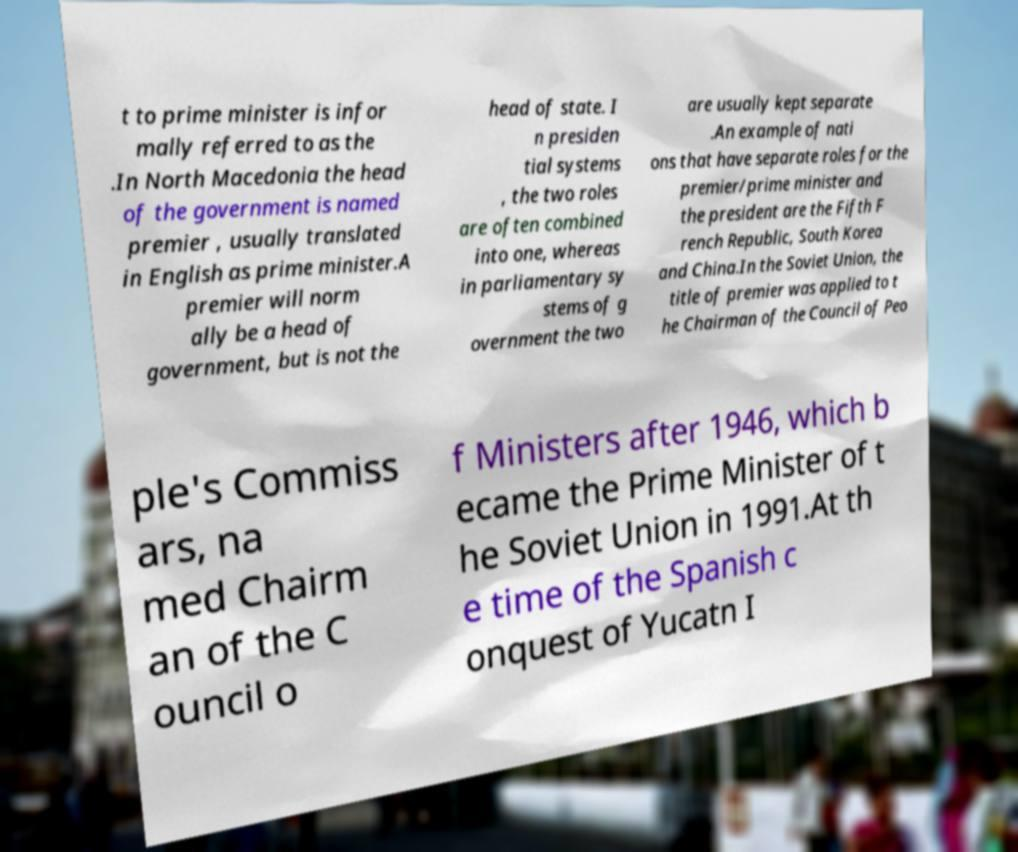Could you extract and type out the text from this image? t to prime minister is infor mally referred to as the .In North Macedonia the head of the government is named premier , usually translated in English as prime minister.A premier will norm ally be a head of government, but is not the head of state. I n presiden tial systems , the two roles are often combined into one, whereas in parliamentary sy stems of g overnment the two are usually kept separate .An example of nati ons that have separate roles for the premier/prime minister and the president are the Fifth F rench Republic, South Korea and China.In the Soviet Union, the title of premier was applied to t he Chairman of the Council of Peo ple's Commiss ars, na med Chairm an of the C ouncil o f Ministers after 1946, which b ecame the Prime Minister of t he Soviet Union in 1991.At th e time of the Spanish c onquest of Yucatn I 